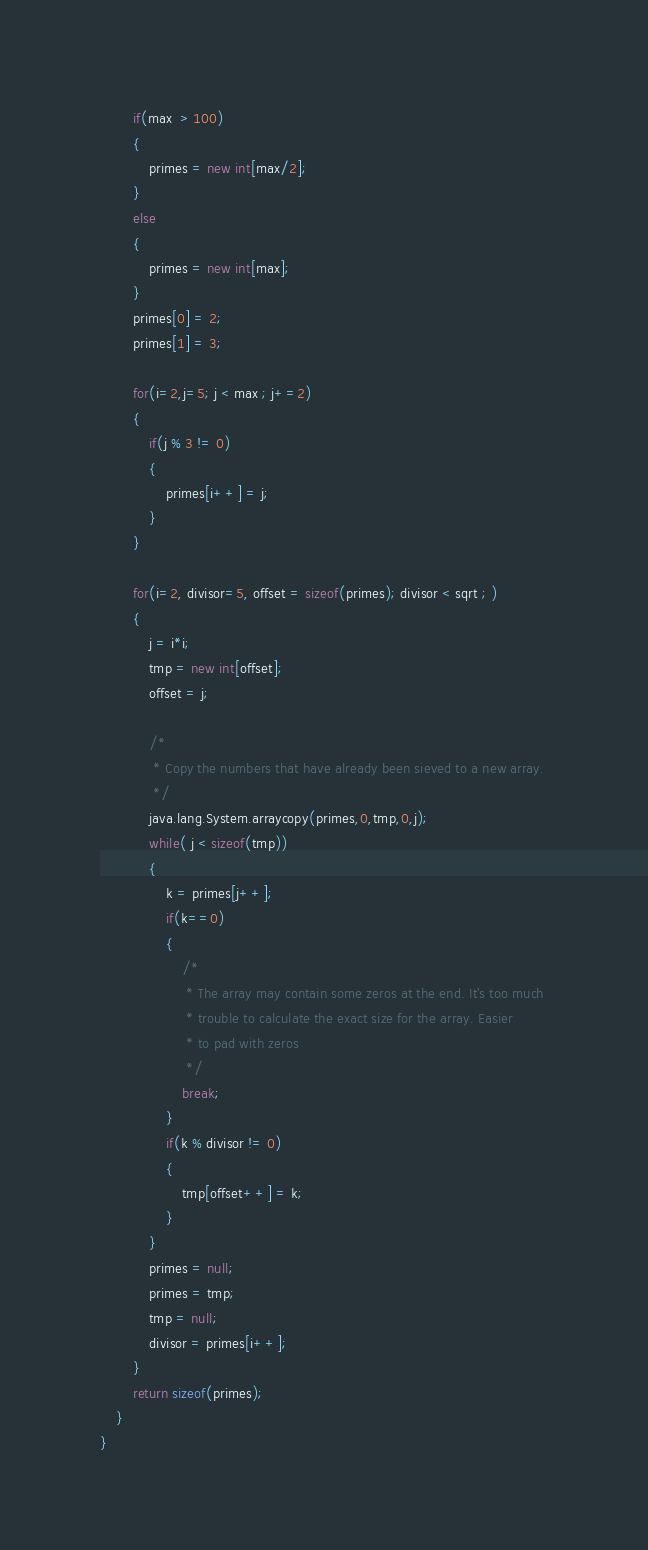<code> <loc_0><loc_0><loc_500><loc_500><_C#_>        if(max  > 100)
        {
            primes = new int[max/2];
        }
        else
        {
            primes = new int[max];
        }
        primes[0] = 2;
        primes[1] = 3;
        
        for(i=2,j=5; j < max ; j+=2)
        {
            if(j % 3 != 0)
            {
                primes[i++] = j;
            }
        }
        
        for(i=2, divisor=5, offset = sizeof(primes); divisor < sqrt ; )
        {
            j = i*i;
            tmp = new int[offset];
            offset = j;

            /* 
             * Copy the numbers that have already been sieved to a new array.
             */
            java.lang.System.arraycopy(primes,0,tmp,0,j);
            while( j < sizeof(tmp))
            {
                k = primes[j++];
                if(k==0)
                {
                    /*
                     * The array may contain some zeros at the end. It's too much 
                     * trouble to calculate the exact size for the array. Easier
                     * to pad with zeros
                     */
                    break;
                }
                if(k % divisor != 0)
                {
                    tmp[offset++] = k;
                }
            }
            primes = null;
            primes = tmp;
            tmp = null;
            divisor = primes[i++];
        }
        return sizeof(primes);
    }
}
</code> 